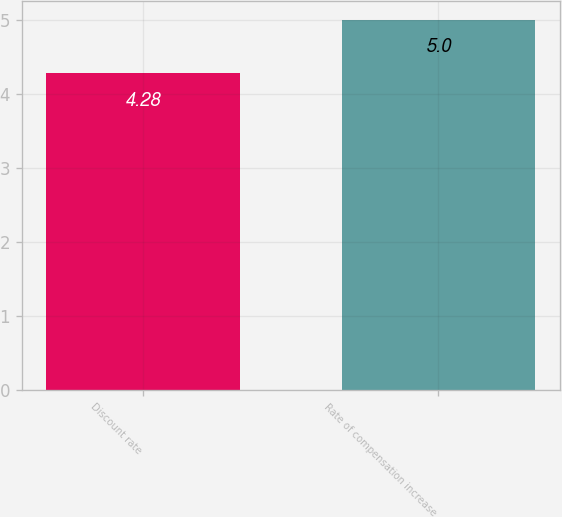Convert chart to OTSL. <chart><loc_0><loc_0><loc_500><loc_500><bar_chart><fcel>Discount rate<fcel>Rate of compensation increase<nl><fcel>4.28<fcel>5<nl></chart> 